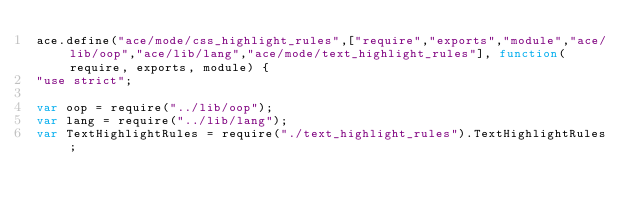Convert code to text. <code><loc_0><loc_0><loc_500><loc_500><_JavaScript_>ace.define("ace/mode/css_highlight_rules",["require","exports","module","ace/lib/oop","ace/lib/lang","ace/mode/text_highlight_rules"], function(require, exports, module) {
"use strict";

var oop = require("../lib/oop");
var lang = require("../lib/lang");
var TextHighlightRules = require("./text_highlight_rules").TextHighlightRules;</code> 